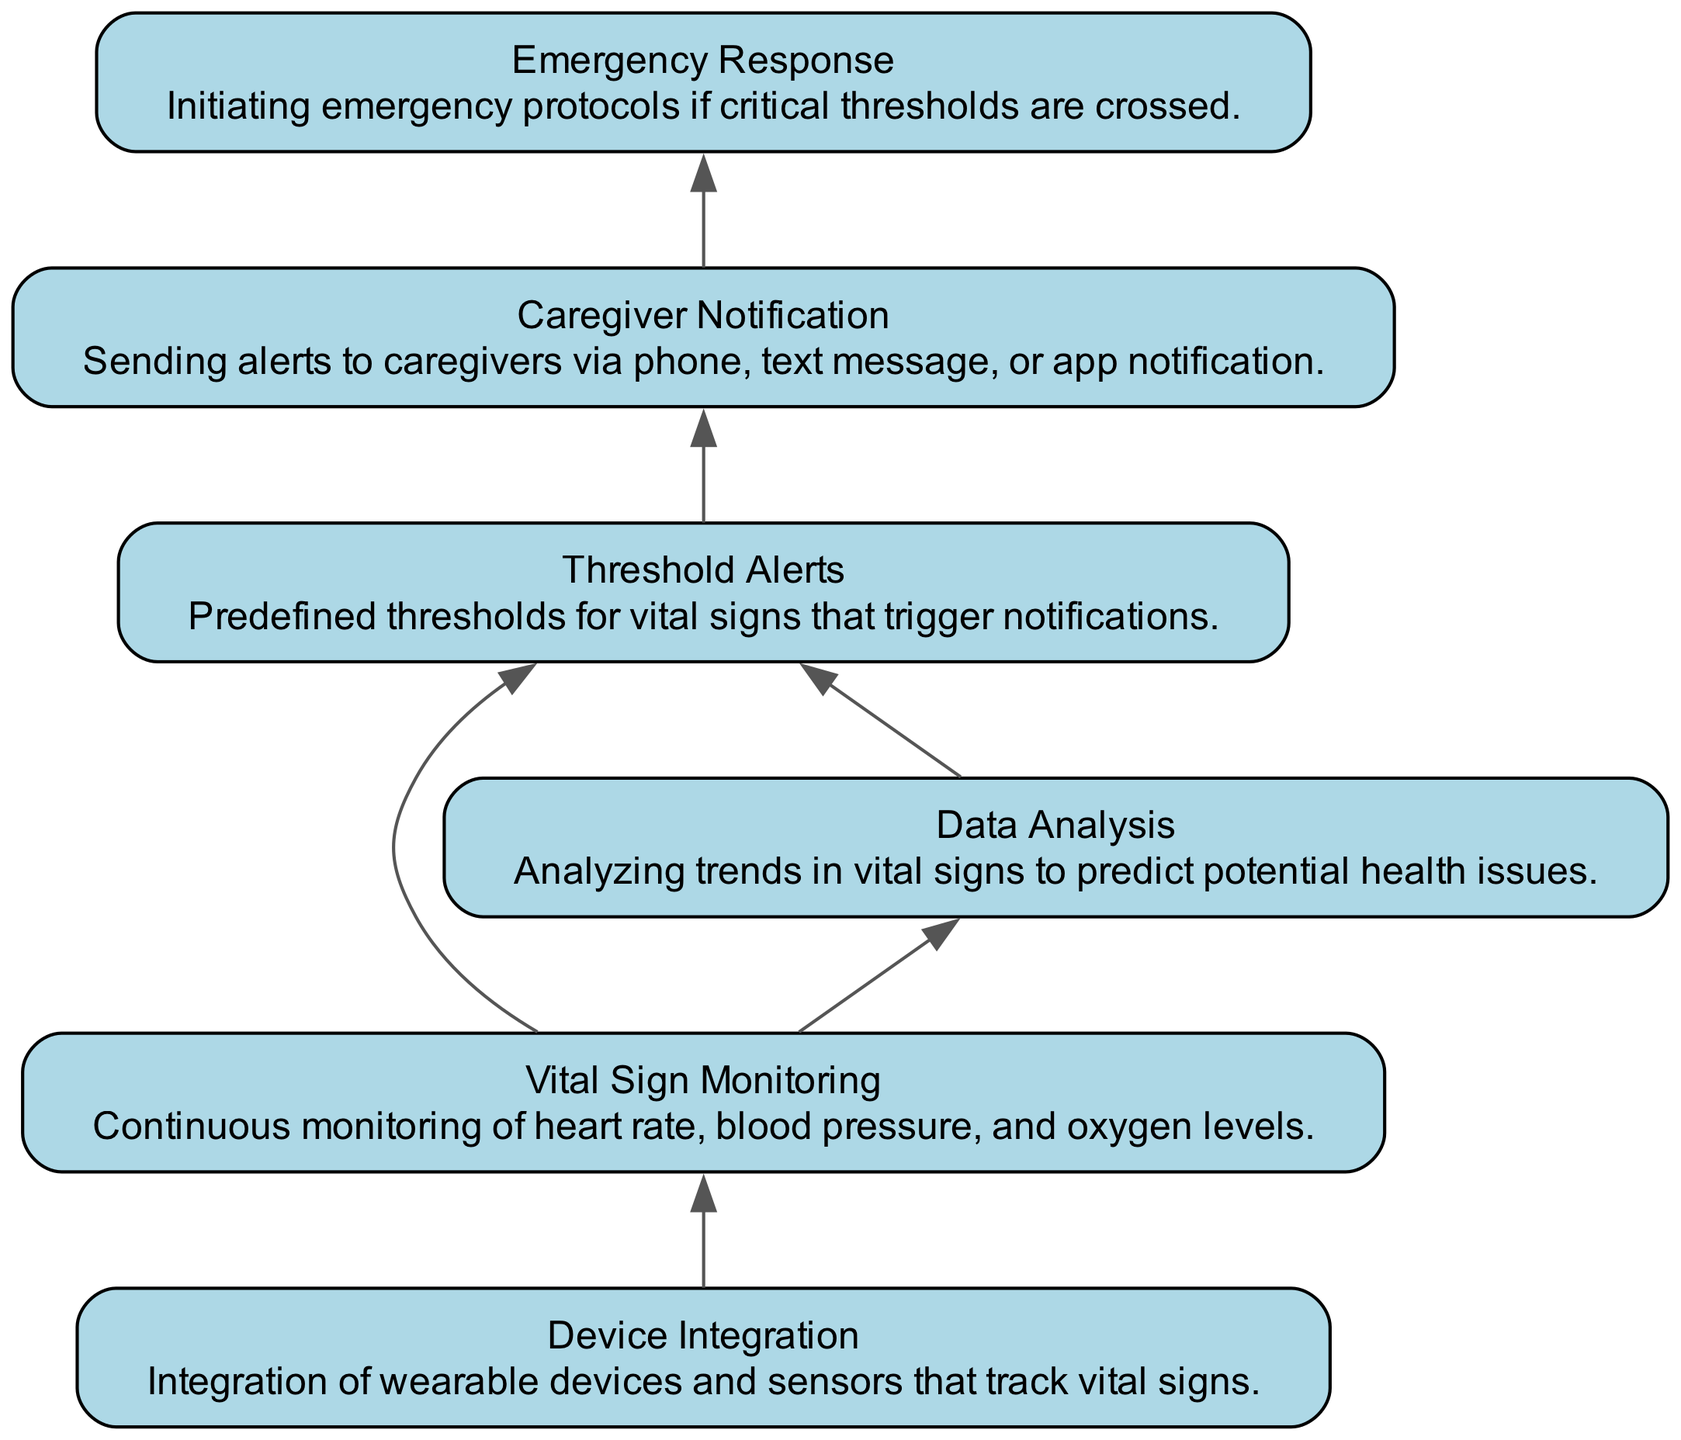What is the first step in the workflow? The first step is identified by looking at the bottom node that leads to further actions. In this diagram, "Device Integration" is at the foundational level, indicating it initiates the entire monitoring process.
Answer: Device Integration How many nodes are in the diagram? The count of distinct elements can be found by enumerating all labeled rectangular nodes within the diagram. There are six nodes representing different components of the workflow.
Answer: Six What triggers "Caregiver Notification"? This notification is triggered by the "Threshold Alerts" node, which receives input based on the monitored vital signs reaching designated pre-set levels. Therefore, after the alerts are generated, they lead directly to notifying caregivers.
Answer: Threshold Alerts Which node connects directly to "Data Analysis"? To find this connection, I scan for edges starting from "Data Analysis" and see which node feeds data into it. Here, "Vital Sign Monitoring" is the node directly connected to "Data Analysis," illustrating that the monitoring data is analyzed to inform alerts.
Answer: Vital Sign Monitoring What is the relationship between "Threshold Alerts" and "Emergency Response"? In the workflow, there is a direct edge from "Caregiver Notification" to "Emergency Response," with "Threshold Alerts" being an upstream node that facilitates the alert process that precedes notification of emergencies. This connection indicates that crossing thresholds could necessitate emergency actions if alerts are disregarded.
Answer: Caregiver Notification How does "Data Analysis" influence "Threshold Alerts"? Data Analysis examines trends from the "Vital Sign Monitoring" and sends updated information back to "Threshold Alerts" for reassessment of the alert criteria. This feedback loop ensures alerts adapt to the person's changing health status based on plotted trends in their vital metrics.
Answer: By feedback loop What are the common vital signs monitored? The diagram explicitly states that heart rate, blood pressure, and oxygen levels are monitored continuously under "Vital Sign Monitoring." These specific signs are crucial for determining the individual's health status in real-time.
Answer: Heart rate, blood pressure, oxygen levels What happens when vital signs cross critical thresholds? When critical thresholds are reached, the established protocol involves prompting "Emergency Response," which signifies that urgent measures or interventions are initiated to ensure patient safety. It is the immediate action taken following alerts.
Answer: Emergency Response 